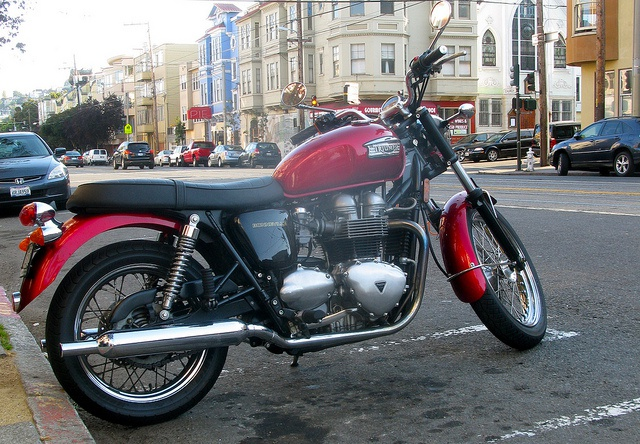Describe the objects in this image and their specific colors. I can see motorcycle in lightgray, black, gray, and darkgray tones, car in lightgray, black, blue, and gray tones, car in lightgray, black, blue, and gray tones, car in lightgray, black, gray, and darkgray tones, and car in lightgray, black, gray, blue, and darkgray tones in this image. 